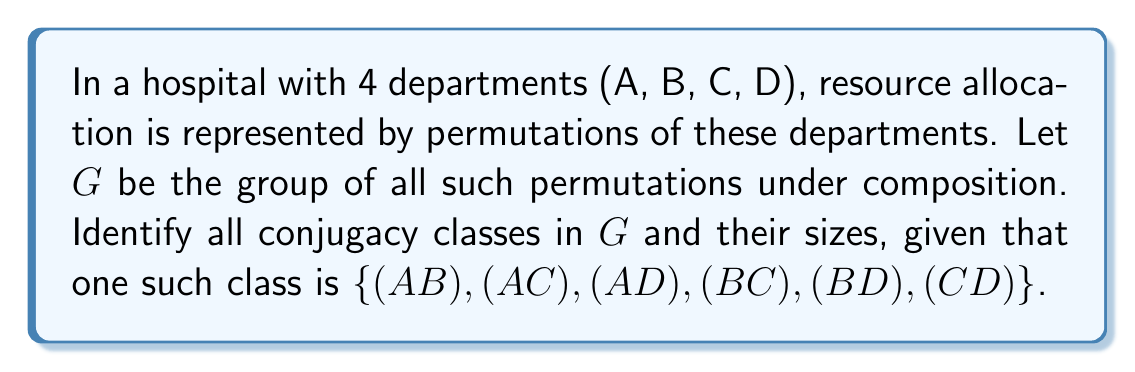Could you help me with this problem? To solve this problem, we need to follow these steps:

1) First, recall that $G$ is isomorphic to $S_4$, the symmetric group on 4 elements.

2) In $S_4$, conjugacy classes are determined by cycle structure. The possible cycle structures are:
   - (1)(1)(1)(1) : identity
   - (2)(1)(1) : 2-cycles
   - (2)(2) : product of two disjoint 2-cycles
   - (3)(1) : 3-cycles
   - (4) : 4-cycles

3) We're given one conjugacy class: $\{(A B), (A C), (A D), (B C), (B D), (C D)\}$. These are all 2-cycles, corresponding to the (2)(1)(1) cycle structure.

4) Let's count the elements in each conjugacy class:

   - Identity: Only one element, $(1)$
   Size: 1

   - 2-cycles (2)(1)(1): We're given this class, size 6

   - Products of two disjoint 2-cycles (2)(2):
   $(A B)(C D)$, $(A C)(B D)$, $(A D)(B C)$
   Size: 3

   - 3-cycles (3)(1):
   $(A B C)$, $(A C B)$, $(A B D)$, $(A D B)$, $(A C D)$, $(A D C)$, $(B C D)$, $(B D C)$
   Size: 8

   - 4-cycles (4):
   $(A B C D)$, $(A B D C)$, $(A C B D)$, $(A C D B)$, $(A D B C)$, $(A D C B)$
   Size: 6

5) We can verify: $1 + 6 + 3 + 8 + 6 = 24 = 4! = |S_4|$

Therefore, these are all the conjugacy classes in $G$.
Answer: The conjugacy classes in $G$ are:

1. $\{(1)\}$ (size 1)
2. $\{(A B), (A C), (A D), (B C), (B D), (C D)\}$ (size 6)
3. $\{(A B)(C D), (A C)(B D), (A D)(B C)\}$ (size 3)
4. $\{(A B C), (A C B), (A B D), (A D B), (A C D), (A D C), (B C D), (B D C)\}$ (size 8)
5. $\{(A B C D), (A B D C), (A C B D), (A C D B), (A D B C), (A D C B)\}$ (size 6) 